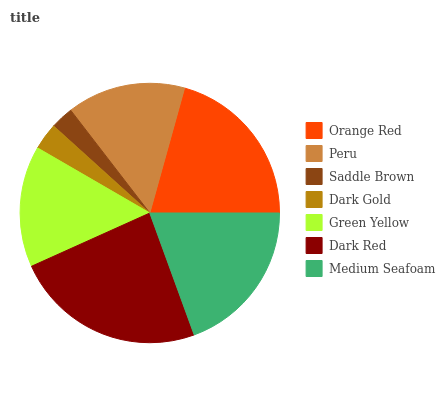Is Saddle Brown the minimum?
Answer yes or no. Yes. Is Dark Red the maximum?
Answer yes or no. Yes. Is Peru the minimum?
Answer yes or no. No. Is Peru the maximum?
Answer yes or no. No. Is Orange Red greater than Peru?
Answer yes or no. Yes. Is Peru less than Orange Red?
Answer yes or no. Yes. Is Peru greater than Orange Red?
Answer yes or no. No. Is Orange Red less than Peru?
Answer yes or no. No. Is Green Yellow the high median?
Answer yes or no. Yes. Is Green Yellow the low median?
Answer yes or no. Yes. Is Saddle Brown the high median?
Answer yes or no. No. Is Peru the low median?
Answer yes or no. No. 